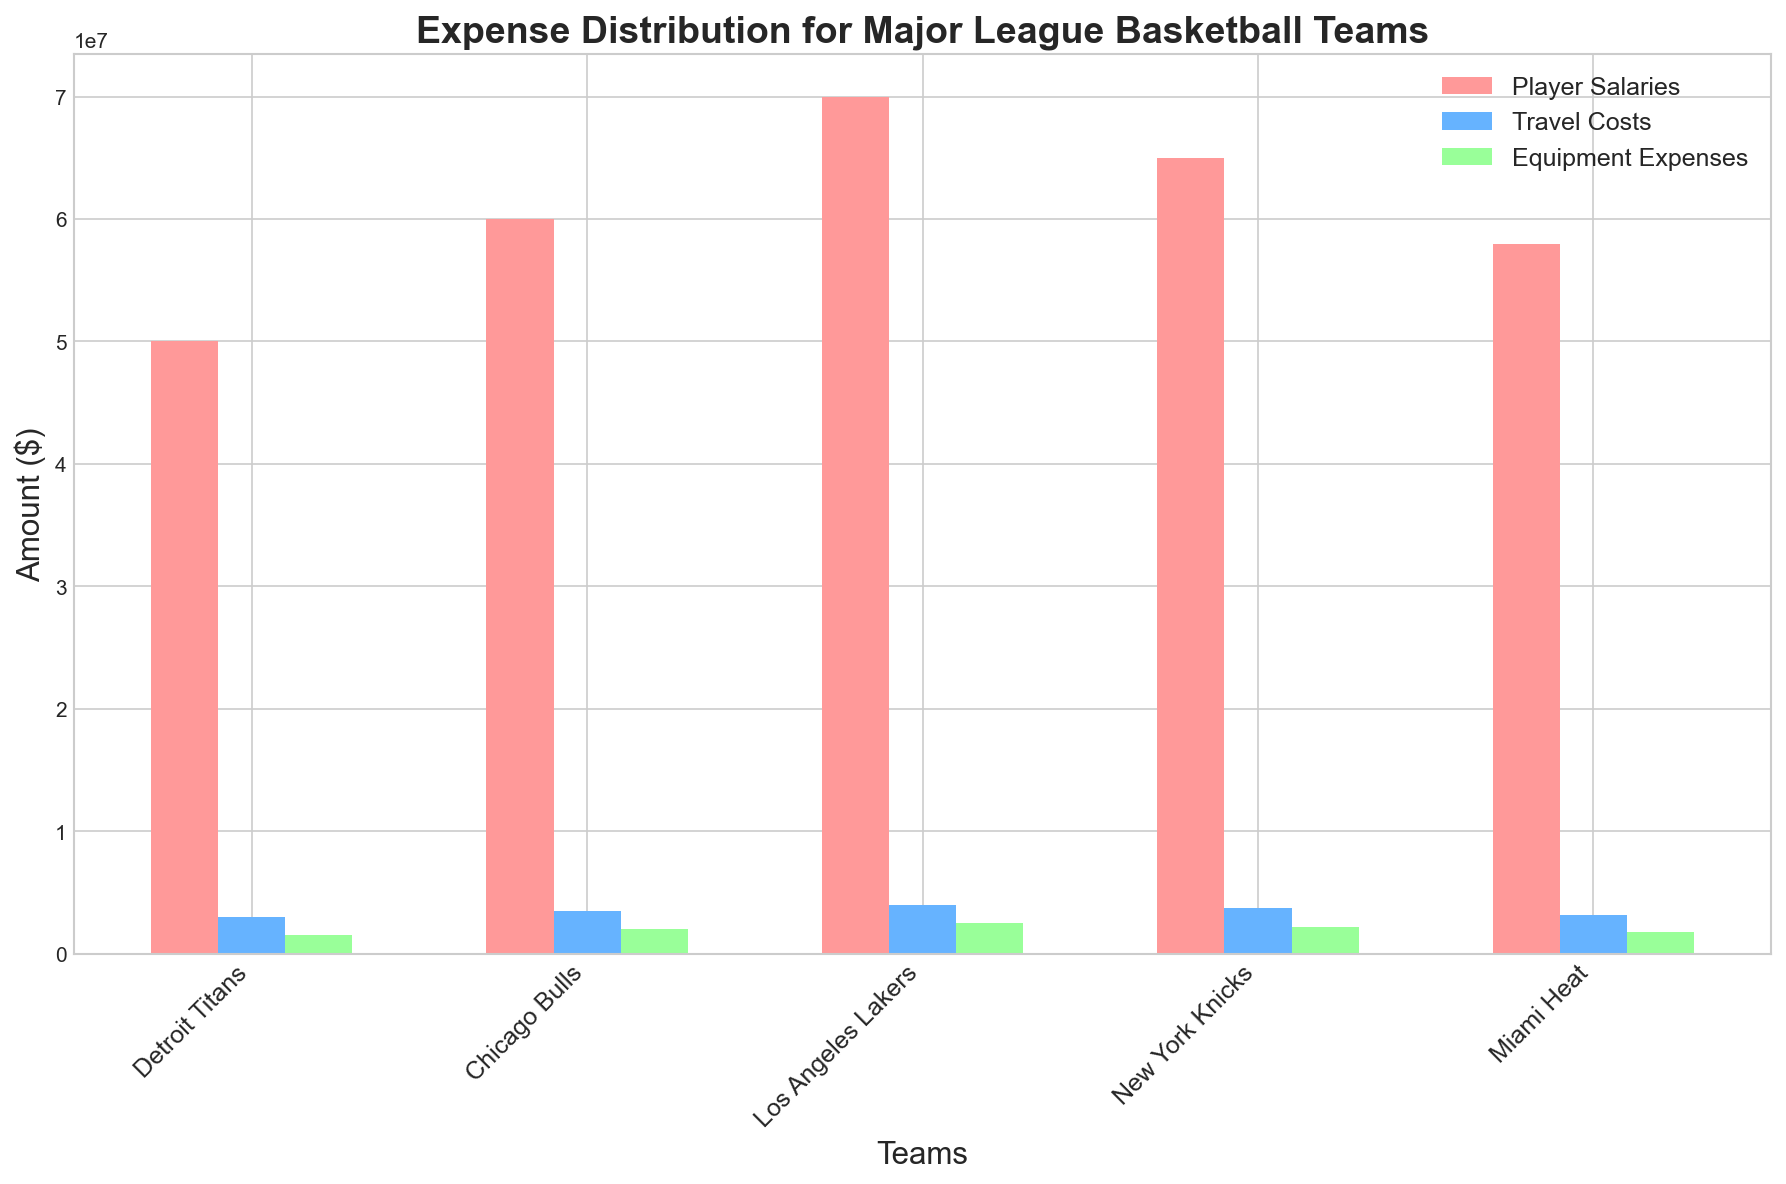Which team spends the most on player salaries? Observing the graph, compare the height of the bars for player salaries across the teams. The tallest bar is for the Los Angeles Lakers' player salaries.
Answer: Los Angeles Lakers Which team has the highest total expenses? To find the team with the highest total expenses, sum the heights of the bars for player salaries, travel costs, and equipment expenses for each team. Los Angeles Lakers: 70000000 + 4000000 + 2500000 = 76500000, Chicago Bulls: 60000000 + 3500000 + 2000000 = 65500000, New York Knicks: 65000000 + 3700000 + 2200000 = 70900000, Detroit Titans: 50000000 + 3000000 + 1500000 = 54500000, Miami Heat: 58000000 + 3200000 + 1800000 = 63000000. The Los Angeles Lakers have the highest total expenses.
Answer: Los Angeles Lakers Which team has the lowest travel costs? Compare the height of the travel costs bars for each team. The shortest bar for travel costs is for the Detroit Titans.
Answer: Detroit Titans What is the difference in equipment expenses between the team with the highest and the team with the lowest equipment expenses? Identify which team has the highest and lowest equipment expenses bars, then calculate the difference. The highest is Los Angeles Lakers (2500000) and the lowest is Detroit Titans (1500000). The difference is 2500000 - 1500000 = 1000000.
Answer: 1000000 How much more is spent on player salaries compared to equipment expenses for the New York Knicks? Look at the bars for player salaries and equipment expenses for New York Knicks and subtract the equipment expenses from the player salaries. Player Salaries: 65000000, Equipment Expenses: 2200000. 65000000 - 2200000 = 62800000.
Answer: 62800000 Which team spends less on travel costs compared to player salaries but more on equipment expenses than travel costs? Analyze each team's bars for the given criteria. Detroit Titans: 50000000 > 3000000 and 3000000 > 1500000 (False). Chicago Bulls: 60000000 > 3500000 and 3500000 > 2000000 (False). Los Angeles Lakers: 70000000 > 4000000 and 4000000 > 2500000 (False). New York Knicks: 65000000 > 3700000 and 3700000 > 2200000 (False). Miami Heat: 58000000 > 3200000 and 3200000 > 1800000 (False). No team meets this condition.
Answer: None 